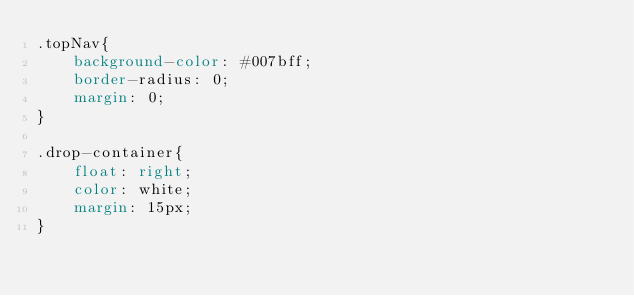Convert code to text. <code><loc_0><loc_0><loc_500><loc_500><_CSS_>.topNav{
    background-color: #007bff;
    border-radius: 0;
    margin: 0;
}

.drop-container{
    float: right;
    color: white;
    margin: 15px;
}
</code> 